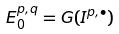<formula> <loc_0><loc_0><loc_500><loc_500>E _ { 0 } ^ { p , q } = G ( I ^ { p , \bullet } )</formula> 